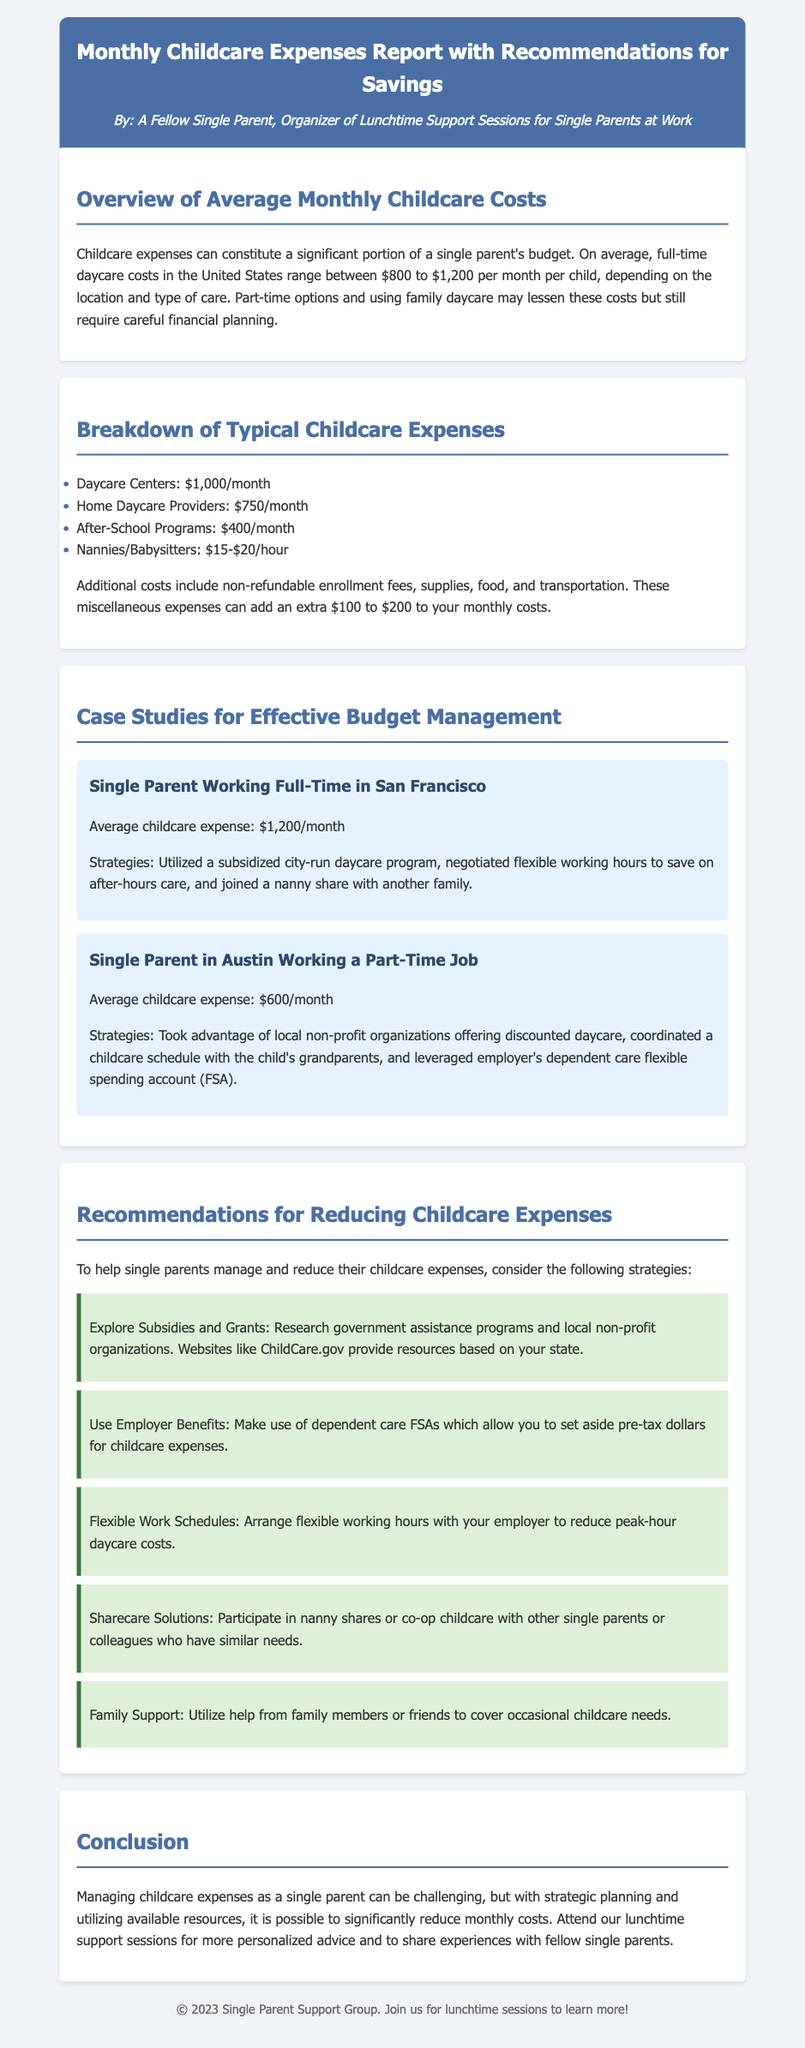What is the average cost of full-time daycare in the United States? The document states that the average cost ranges between $800 to $1,200 per month per child.
Answer: $800 to $1,200 What is the monthly cost of home daycare providers? From the breakdown of typical childcare expenses, home daycare providers cost $750/month.
Answer: $750/month How much can miscellaneous expenses add to monthly childcare costs? The document mentions that miscellaneous expenses can add an extra $100 to $200.
Answer: $100 to $200 What strategy did the single parent in San Francisco use to manage costs? The single parent utilized a subsidized city-run daycare program and negotiated flexible working hours.
Answer: Subsidized city-run daycare program What recommendation suggests using government assistance programs? The recommendation is to explore subsidies and grants, with resources available at ChildCare.gov.
Answer: Explore Subsidies and Grants What type of account can help save on childcare expenses pre-tax? The document refers to dependent care flexible spending accounts (FSA).
Answer: Dependent care FSA What is one benefit of participating in nanny shares? The document suggests that nanny shares can help reduce expenses through shared care with others.
Answer: Reduce expenses Who can help with occasional childcare needs according to the recommendations? The document states that family members or friends can help cover occasional childcare needs.
Answer: Family members or friends 